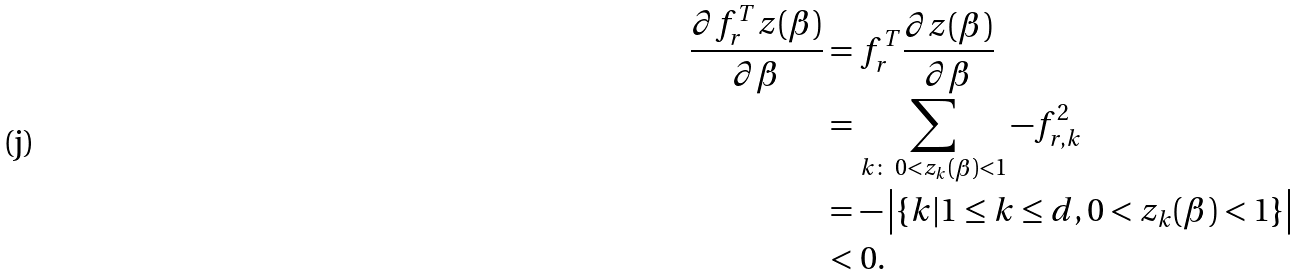<formula> <loc_0><loc_0><loc_500><loc_500>\frac { \partial f _ { r } ^ { T } z ( \beta ) } { \partial \beta } & = f _ { r } ^ { T } \frac { \partial z ( \beta ) } { \partial \beta } \\ & = \sum _ { k \colon \ 0 < z _ { k } ( \beta ) < 1 } - f _ { r , k } ^ { 2 } \\ & = - \left | \{ k | 1 \leq k \leq d , 0 < z _ { k } ( \beta ) < 1 \} \right | \\ & < 0 .</formula> 